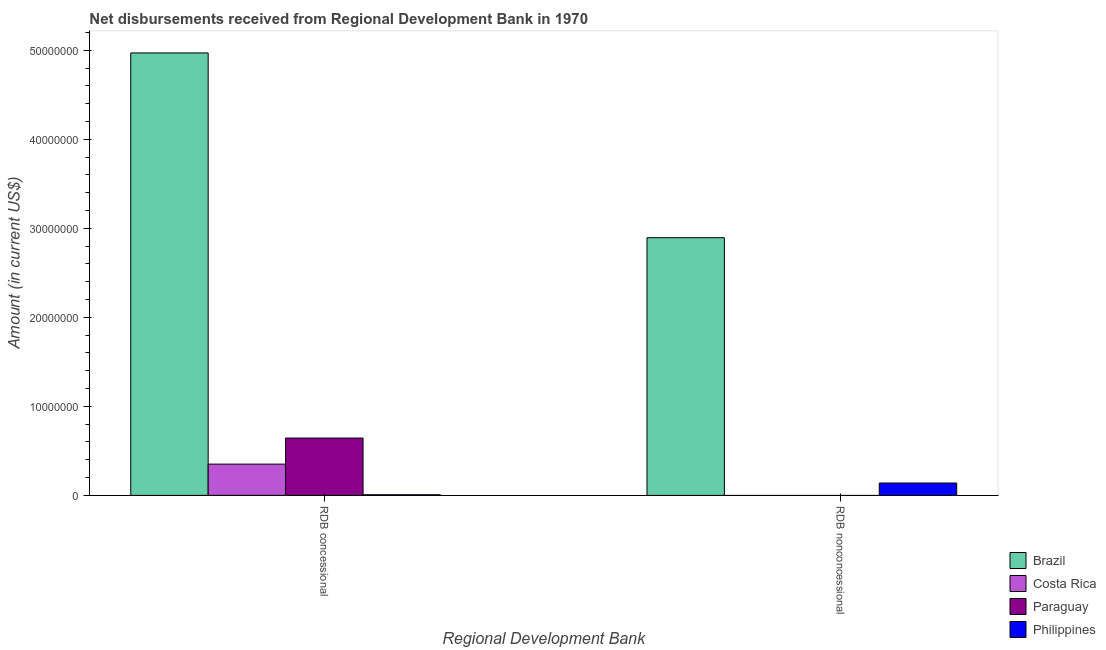How many different coloured bars are there?
Offer a terse response. 4. How many groups of bars are there?
Keep it short and to the point. 2. Are the number of bars on each tick of the X-axis equal?
Provide a succinct answer. No. What is the label of the 1st group of bars from the left?
Your answer should be very brief. RDB concessional. What is the net non concessional disbursements from rdb in Paraguay?
Offer a very short reply. 0. Across all countries, what is the maximum net concessional disbursements from rdb?
Provide a short and direct response. 4.97e+07. Across all countries, what is the minimum net concessional disbursements from rdb?
Ensure brevity in your answer.  6.90e+04. What is the total net non concessional disbursements from rdb in the graph?
Keep it short and to the point. 3.03e+07. What is the difference between the net concessional disbursements from rdb in Brazil and that in Costa Rica?
Offer a very short reply. 4.62e+07. What is the difference between the net concessional disbursements from rdb in Paraguay and the net non concessional disbursements from rdb in Brazil?
Provide a succinct answer. -2.25e+07. What is the average net non concessional disbursements from rdb per country?
Offer a terse response. 7.59e+06. What is the difference between the net concessional disbursements from rdb and net non concessional disbursements from rdb in Brazil?
Make the answer very short. 2.08e+07. In how many countries, is the net concessional disbursements from rdb greater than 46000000 US$?
Keep it short and to the point. 1. What is the ratio of the net concessional disbursements from rdb in Paraguay to that in Philippines?
Provide a short and direct response. 93.38. How many bars are there?
Make the answer very short. 6. How many countries are there in the graph?
Offer a terse response. 4. What is the difference between two consecutive major ticks on the Y-axis?
Offer a terse response. 1.00e+07. Does the graph contain any zero values?
Give a very brief answer. Yes. Does the graph contain grids?
Make the answer very short. No. Where does the legend appear in the graph?
Offer a terse response. Bottom right. How many legend labels are there?
Keep it short and to the point. 4. What is the title of the graph?
Provide a short and direct response. Net disbursements received from Regional Development Bank in 1970. Does "Indonesia" appear as one of the legend labels in the graph?
Ensure brevity in your answer.  No. What is the label or title of the X-axis?
Provide a succinct answer. Regional Development Bank. What is the label or title of the Y-axis?
Provide a succinct answer. Amount (in current US$). What is the Amount (in current US$) in Brazil in RDB concessional?
Ensure brevity in your answer.  4.97e+07. What is the Amount (in current US$) of Costa Rica in RDB concessional?
Your answer should be very brief. 3.51e+06. What is the Amount (in current US$) of Paraguay in RDB concessional?
Ensure brevity in your answer.  6.44e+06. What is the Amount (in current US$) of Philippines in RDB concessional?
Ensure brevity in your answer.  6.90e+04. What is the Amount (in current US$) of Brazil in RDB nonconcessional?
Your response must be concise. 2.90e+07. What is the Amount (in current US$) in Philippines in RDB nonconcessional?
Offer a very short reply. 1.39e+06. Across all Regional Development Bank, what is the maximum Amount (in current US$) in Brazil?
Your answer should be compact. 4.97e+07. Across all Regional Development Bank, what is the maximum Amount (in current US$) in Costa Rica?
Make the answer very short. 3.51e+06. Across all Regional Development Bank, what is the maximum Amount (in current US$) of Paraguay?
Make the answer very short. 6.44e+06. Across all Regional Development Bank, what is the maximum Amount (in current US$) of Philippines?
Give a very brief answer. 1.39e+06. Across all Regional Development Bank, what is the minimum Amount (in current US$) of Brazil?
Your response must be concise. 2.90e+07. Across all Regional Development Bank, what is the minimum Amount (in current US$) of Costa Rica?
Make the answer very short. 0. Across all Regional Development Bank, what is the minimum Amount (in current US$) in Paraguay?
Provide a succinct answer. 0. Across all Regional Development Bank, what is the minimum Amount (in current US$) in Philippines?
Give a very brief answer. 6.90e+04. What is the total Amount (in current US$) in Brazil in the graph?
Your response must be concise. 7.87e+07. What is the total Amount (in current US$) of Costa Rica in the graph?
Your response must be concise. 3.51e+06. What is the total Amount (in current US$) of Paraguay in the graph?
Offer a terse response. 6.44e+06. What is the total Amount (in current US$) of Philippines in the graph?
Offer a very short reply. 1.46e+06. What is the difference between the Amount (in current US$) in Brazil in RDB concessional and that in RDB nonconcessional?
Offer a terse response. 2.08e+07. What is the difference between the Amount (in current US$) of Philippines in RDB concessional and that in RDB nonconcessional?
Offer a terse response. -1.32e+06. What is the difference between the Amount (in current US$) in Brazil in RDB concessional and the Amount (in current US$) in Philippines in RDB nonconcessional?
Your response must be concise. 4.83e+07. What is the difference between the Amount (in current US$) in Costa Rica in RDB concessional and the Amount (in current US$) in Philippines in RDB nonconcessional?
Provide a succinct answer. 2.12e+06. What is the difference between the Amount (in current US$) of Paraguay in RDB concessional and the Amount (in current US$) of Philippines in RDB nonconcessional?
Ensure brevity in your answer.  5.05e+06. What is the average Amount (in current US$) of Brazil per Regional Development Bank?
Provide a succinct answer. 3.93e+07. What is the average Amount (in current US$) in Costa Rica per Regional Development Bank?
Your answer should be compact. 1.76e+06. What is the average Amount (in current US$) of Paraguay per Regional Development Bank?
Keep it short and to the point. 3.22e+06. What is the average Amount (in current US$) of Philippines per Regional Development Bank?
Keep it short and to the point. 7.29e+05. What is the difference between the Amount (in current US$) in Brazil and Amount (in current US$) in Costa Rica in RDB concessional?
Your answer should be very brief. 4.62e+07. What is the difference between the Amount (in current US$) in Brazil and Amount (in current US$) in Paraguay in RDB concessional?
Ensure brevity in your answer.  4.33e+07. What is the difference between the Amount (in current US$) of Brazil and Amount (in current US$) of Philippines in RDB concessional?
Your answer should be very brief. 4.96e+07. What is the difference between the Amount (in current US$) of Costa Rica and Amount (in current US$) of Paraguay in RDB concessional?
Your answer should be compact. -2.93e+06. What is the difference between the Amount (in current US$) of Costa Rica and Amount (in current US$) of Philippines in RDB concessional?
Provide a short and direct response. 3.44e+06. What is the difference between the Amount (in current US$) in Paraguay and Amount (in current US$) in Philippines in RDB concessional?
Provide a short and direct response. 6.37e+06. What is the difference between the Amount (in current US$) of Brazil and Amount (in current US$) of Philippines in RDB nonconcessional?
Your response must be concise. 2.76e+07. What is the ratio of the Amount (in current US$) of Brazil in RDB concessional to that in RDB nonconcessional?
Offer a terse response. 1.72. What is the ratio of the Amount (in current US$) of Philippines in RDB concessional to that in RDB nonconcessional?
Your response must be concise. 0.05. What is the difference between the highest and the second highest Amount (in current US$) in Brazil?
Keep it short and to the point. 2.08e+07. What is the difference between the highest and the second highest Amount (in current US$) in Philippines?
Your answer should be compact. 1.32e+06. What is the difference between the highest and the lowest Amount (in current US$) of Brazil?
Your response must be concise. 2.08e+07. What is the difference between the highest and the lowest Amount (in current US$) in Costa Rica?
Ensure brevity in your answer.  3.51e+06. What is the difference between the highest and the lowest Amount (in current US$) in Paraguay?
Ensure brevity in your answer.  6.44e+06. What is the difference between the highest and the lowest Amount (in current US$) in Philippines?
Make the answer very short. 1.32e+06. 